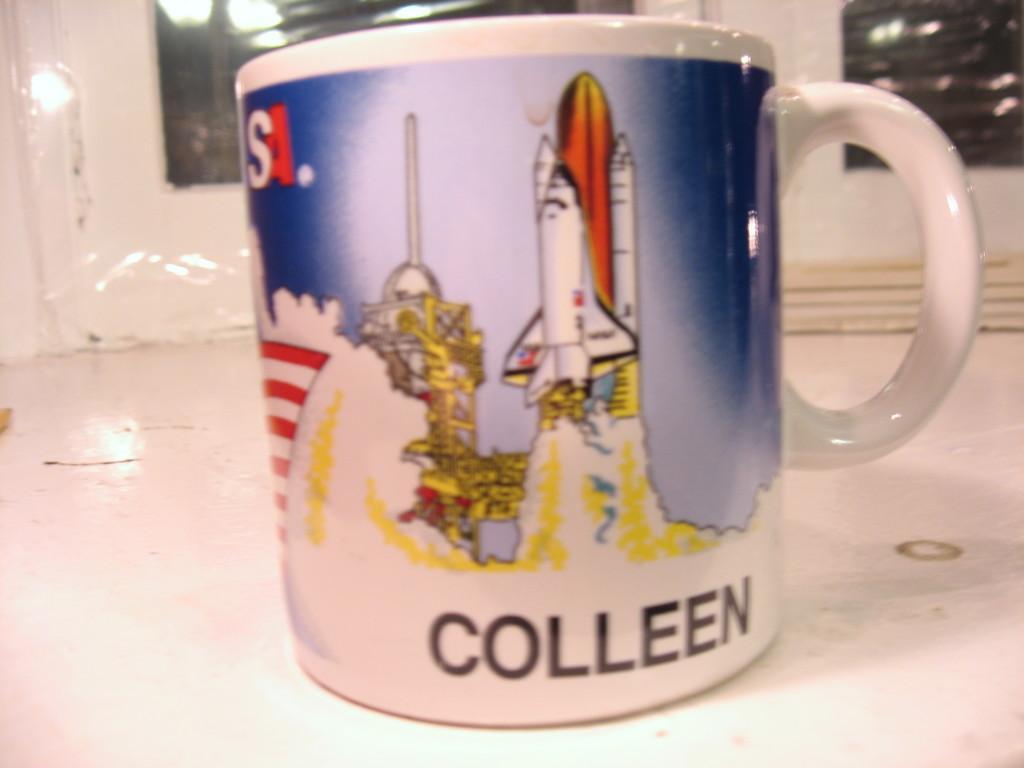How would you summarize this image in a sentence or two? There is a cup on a surface. On the cup there is something written. Also there is a drawing of rocket. In the back there is a wall and a glass window. On the glass window there are reflections of lights. 